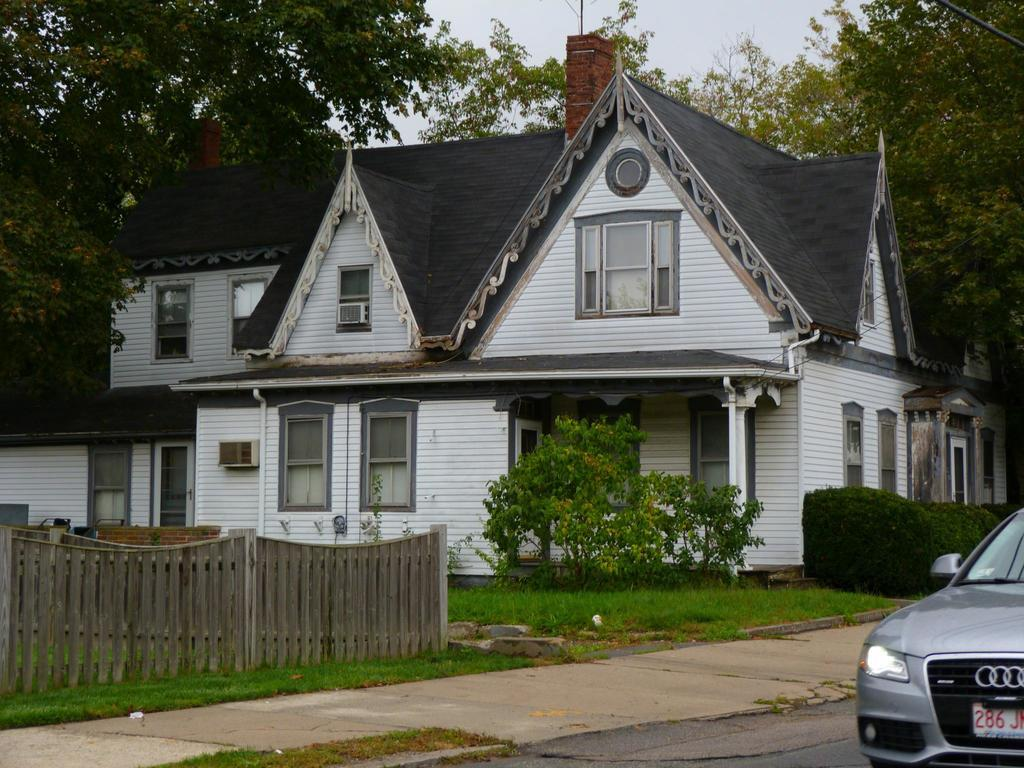What is the main subject in the foreground of the image? There is a car in the foreground of the image. What is located next to the car in the foreground? There is a wooden boundary in the foreground of the image. What can be seen in the background of the image? There are plants, trees, a house, and the sky visible in the background of the image. What type of clam is being used to blow up the car in the image? There is no clam or any indication of the car being blown up in the image. 